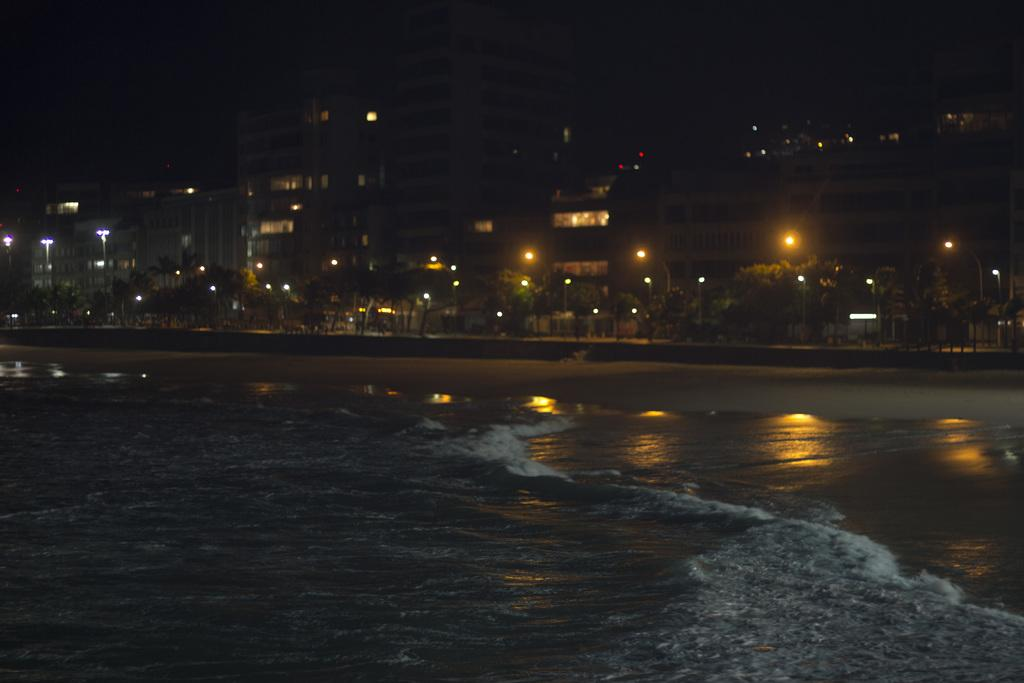What is in the foreground of the image? There is a water body in the foreground of the image. What can be seen in the middle of the image? Trees and lights are visible in the middle of the image. What type of structures are observable at the top of the image? Buildings are observable at the top of the image. How many drops of soda can be seen falling from the trees in the image? There are no drops of soda present in the image; it features a water body, trees, lights, and buildings. Is there a library visible in the image? There is no library present in the image. 